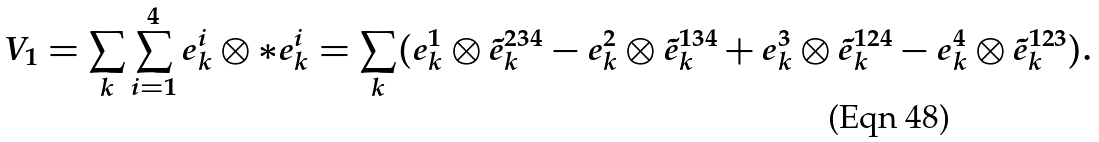Convert formula to latex. <formula><loc_0><loc_0><loc_500><loc_500>V _ { 1 } = \sum _ { k } \sum _ { i = 1 } ^ { 4 } e _ { k } ^ { i } \otimes \ast e _ { k } ^ { i } = \sum _ { k } ( e _ { k } ^ { 1 } \otimes \tilde { e } _ { k } ^ { 2 3 4 } - e _ { k } ^ { 2 } \otimes \tilde { e } _ { k } ^ { 1 3 4 } + e _ { k } ^ { 3 } \otimes \tilde { e } _ { k } ^ { 1 2 4 } - e _ { k } ^ { 4 } \otimes \tilde { e } _ { k } ^ { 1 2 3 } ) .</formula> 